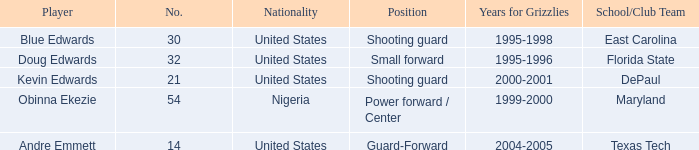When did no. 32 play for grizzles 1995-1996. 